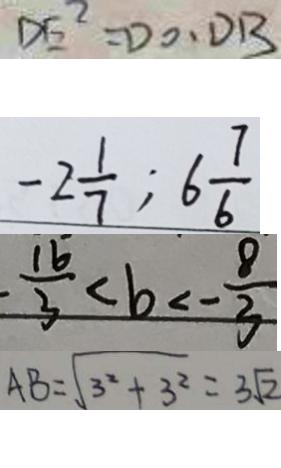Convert formula to latex. <formula><loc_0><loc_0><loc_500><loc_500>D E ^ { 2 } = D O \cdot D B 
 - 2 \frac { 1 } { 7 } ; 6 \frac { 7 } { 6 } 
 - \frac { 1 6 } { 3 } < b < - \frac { 8 } { 3 } 
 A B = \sqrt { 3 ^ { 2 } + 3 ^ { 2 } } = 3 \sqrt { 2 }</formula> 